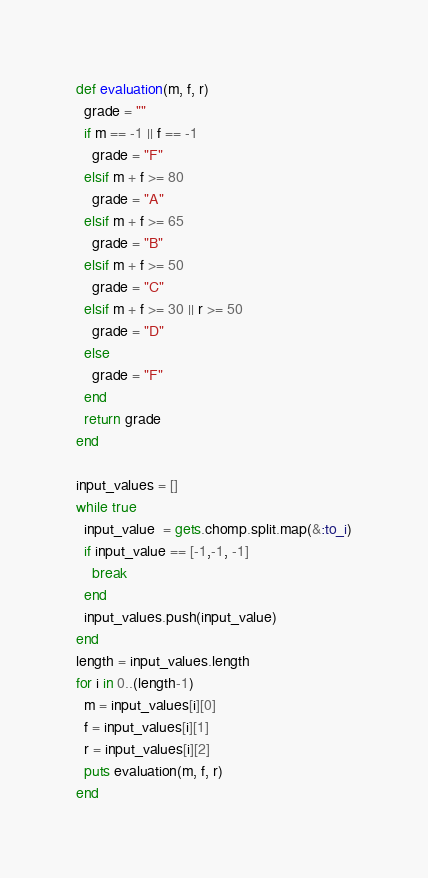<code> <loc_0><loc_0><loc_500><loc_500><_Ruby_>def evaluation(m, f, r)
  grade = ""
  if m == -1 || f == -1
    grade = "F"
  elsif m + f >= 80
    grade = "A"
  elsif m + f >= 65
    grade = "B"
  elsif m + f >= 50
    grade = "C"
  elsif m + f >= 30 || r >= 50
    grade = "D"
  else
    grade = "F"
  end
  return grade
end

input_values = []
while true
  input_value  = gets.chomp.split.map(&:to_i)
  if input_value == [-1,-1, -1]
    break
  end
  input_values.push(input_value)
end
length = input_values.length
for i in 0..(length-1)
  m = input_values[i][0]
  f = input_values[i][1]
  r = input_values[i][2]
  puts evaluation(m, f, r)
end</code> 